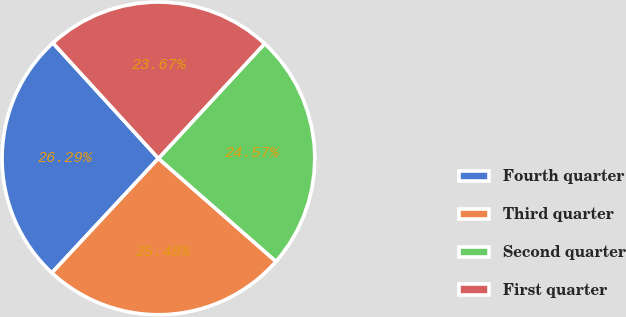<chart> <loc_0><loc_0><loc_500><loc_500><pie_chart><fcel>Fourth quarter<fcel>Third quarter<fcel>Second quarter<fcel>First quarter<nl><fcel>26.29%<fcel>25.48%<fcel>24.57%<fcel>23.67%<nl></chart> 